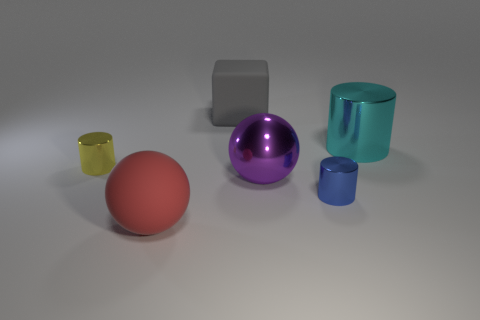Subtract all small cylinders. How many cylinders are left? 1 Subtract all balls. How many objects are left? 4 Add 1 gray blocks. How many objects exist? 7 Subtract all yellow cylinders. How many cylinders are left? 2 Subtract all big cyan metallic cylinders. Subtract all gray blocks. How many objects are left? 4 Add 3 tiny blue things. How many tiny blue things are left? 4 Add 5 small blue metallic objects. How many small blue metallic objects exist? 6 Subtract 0 red cylinders. How many objects are left? 6 Subtract 1 cubes. How many cubes are left? 0 Subtract all purple blocks. Subtract all green spheres. How many blocks are left? 1 